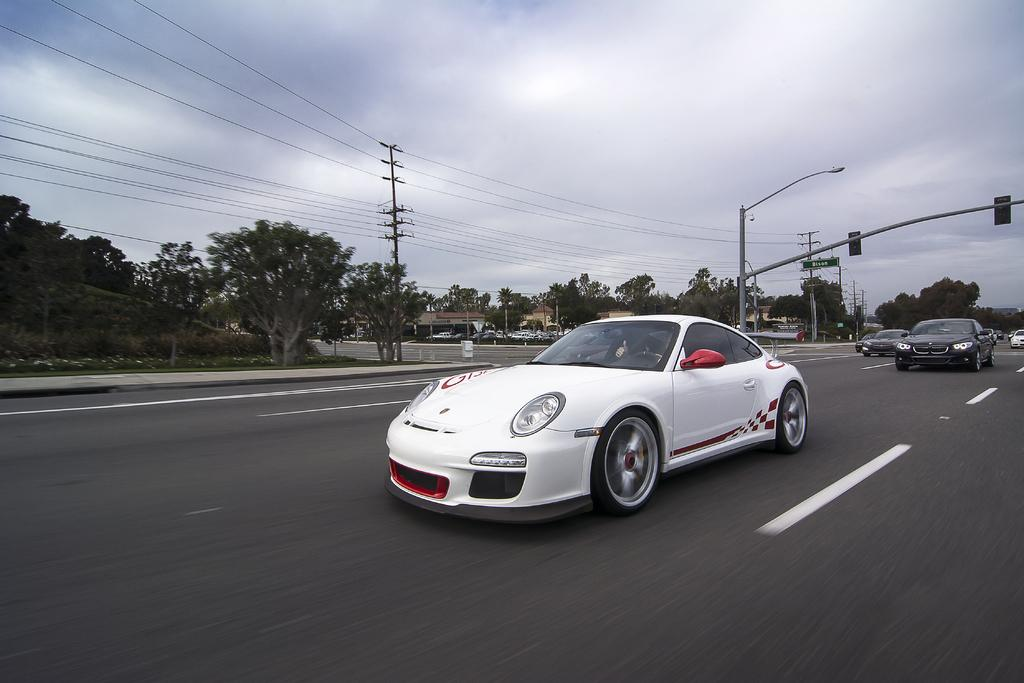What is happening on the road in the image? Vehicles are passing on the road in the image. What infrastructure elements can be seen alongside the road? Electrical poles with wires and light poles are present in the image. What type of vegetation is visible in the image? Trees are present in the image. How would you describe the weather in the image? The sky is cloudy in the image. How many pumps are visible in the image? There are no pumps present in the image. What is the mass of the electrical poles in the image? The mass of the electrical poles cannot be determined from the image alone. 